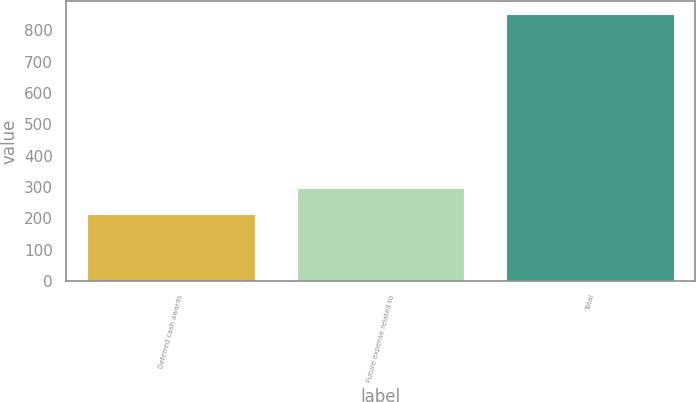Convert chart. <chart><loc_0><loc_0><loc_500><loc_500><bar_chart><fcel>Deferred cash awards<fcel>Future expense related to<fcel>Total<nl><fcel>215<fcel>297<fcel>851<nl></chart> 